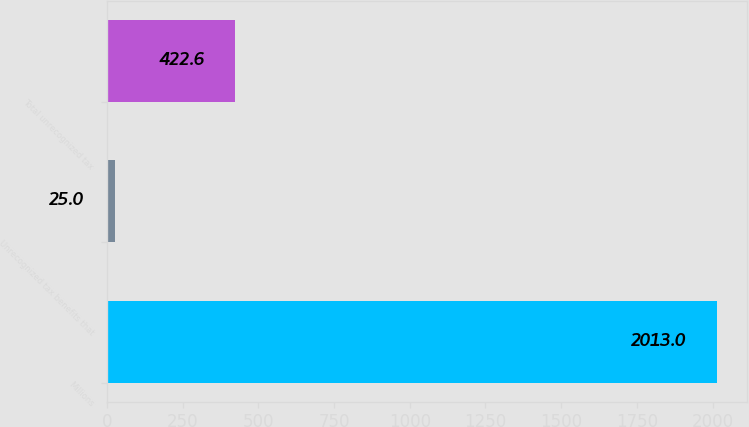<chart> <loc_0><loc_0><loc_500><loc_500><bar_chart><fcel>Millions<fcel>Unrecognized tax benefits that<fcel>Total unrecognized tax<nl><fcel>2013<fcel>25<fcel>422.6<nl></chart> 